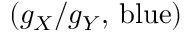<formula> <loc_0><loc_0><loc_500><loc_500>( g _ { X } / g _ { Y } , \, b l u e )</formula> 